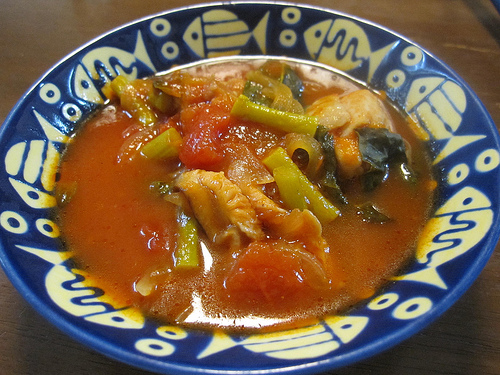<image>
Is the food in front of the bowl? No. The food is not in front of the bowl. The spatial positioning shows a different relationship between these objects. Is the fish decoration above the plate? No. The fish decoration is not positioned above the plate. The vertical arrangement shows a different relationship. 